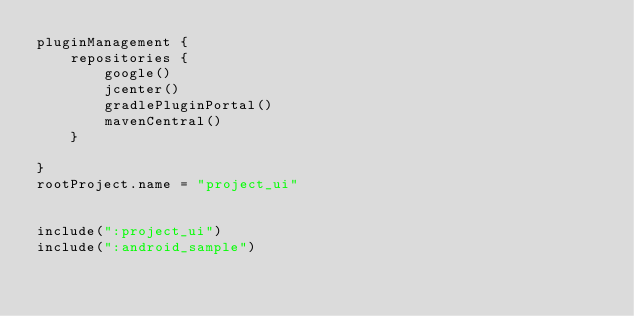<code> <loc_0><loc_0><loc_500><loc_500><_Kotlin_>pluginManagement {
    repositories {
        google()
        jcenter()
        gradlePluginPortal()
        mavenCentral()
    }
    
}
rootProject.name = "project_ui"


include(":project_ui")
include(":android_sample")

</code> 